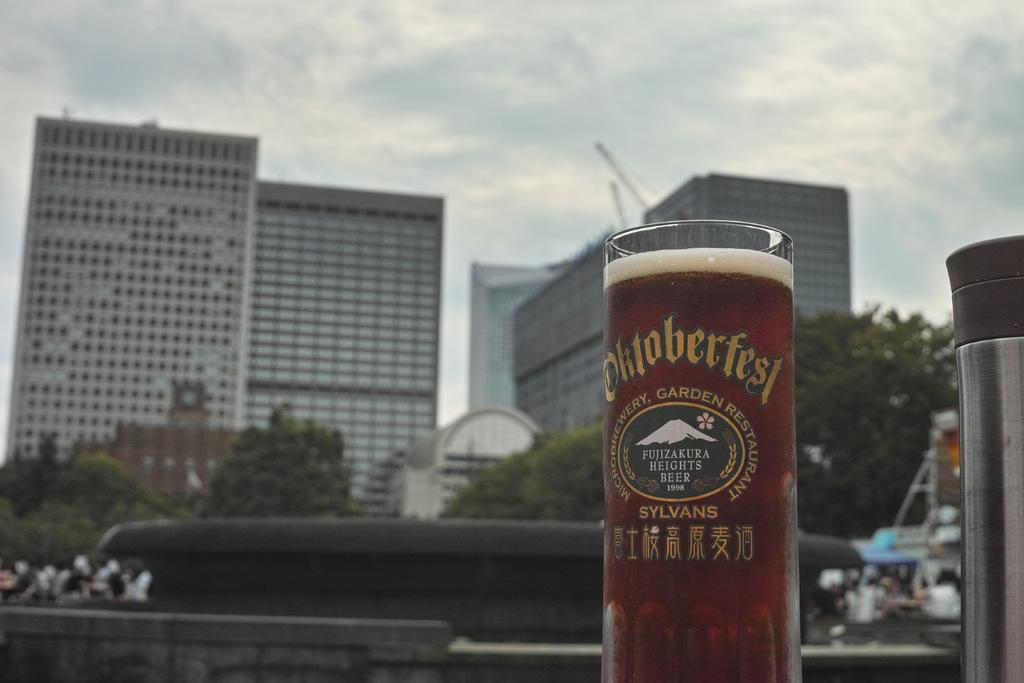<image>
Give a short and clear explanation of the subsequent image. A tall beer glass with the words Oktoberfest written on it as the glass is filled with beer and city buildings are in the background. 